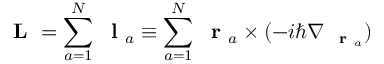Convert formula to latex. <formula><loc_0><loc_0><loc_500><loc_500>L = \sum _ { a = 1 } ^ { N } l _ { a } \equiv \sum _ { a = 1 } ^ { N } r _ { a } \times ( - i \hbar { \nabla } _ { r _ { a } } )</formula> 